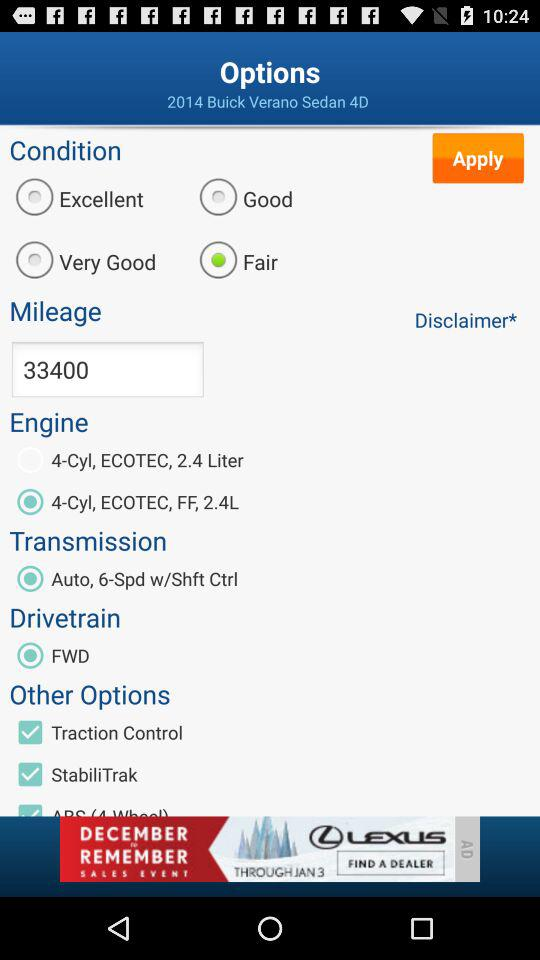How many seats does the 2014 sedan have?
When the provided information is insufficient, respond with <no answer>. <no answer> 